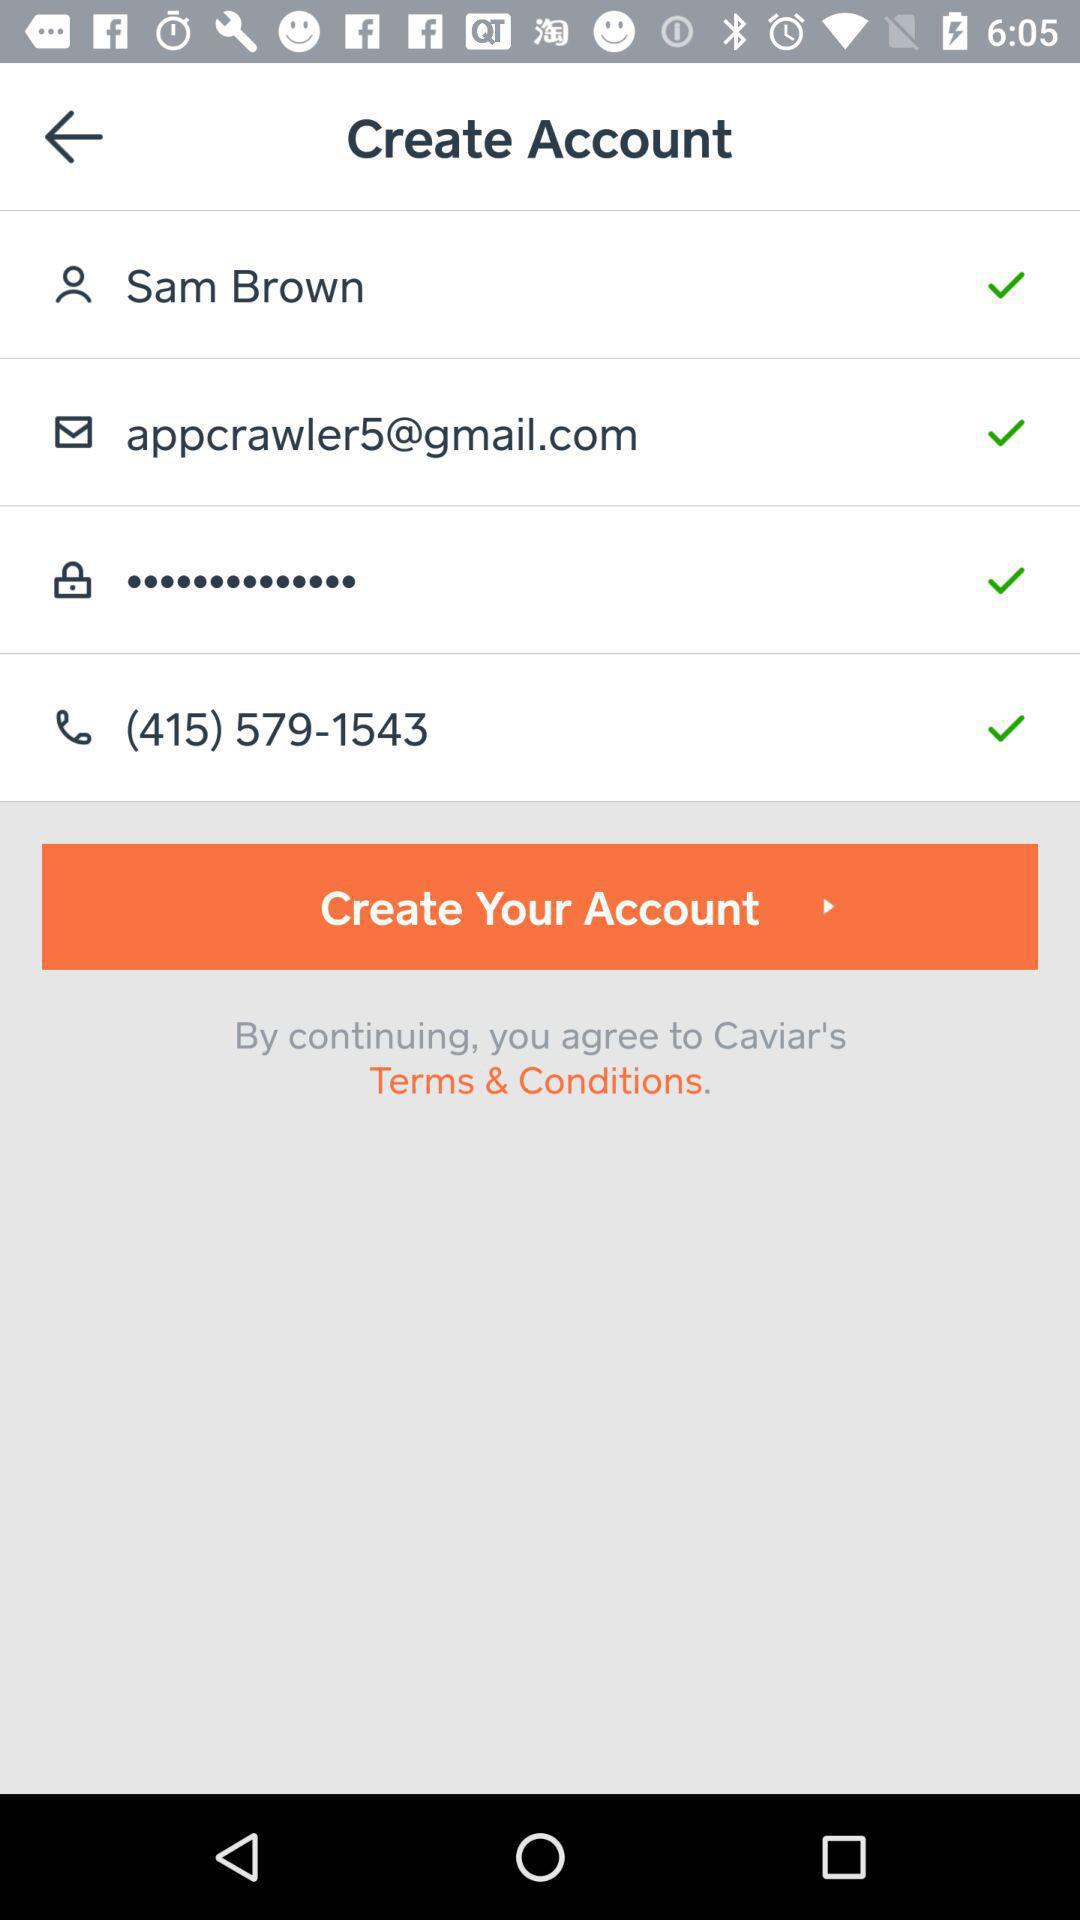How many fields on this form have a check mark next to them?
Answer the question using a single word or phrase. 4 